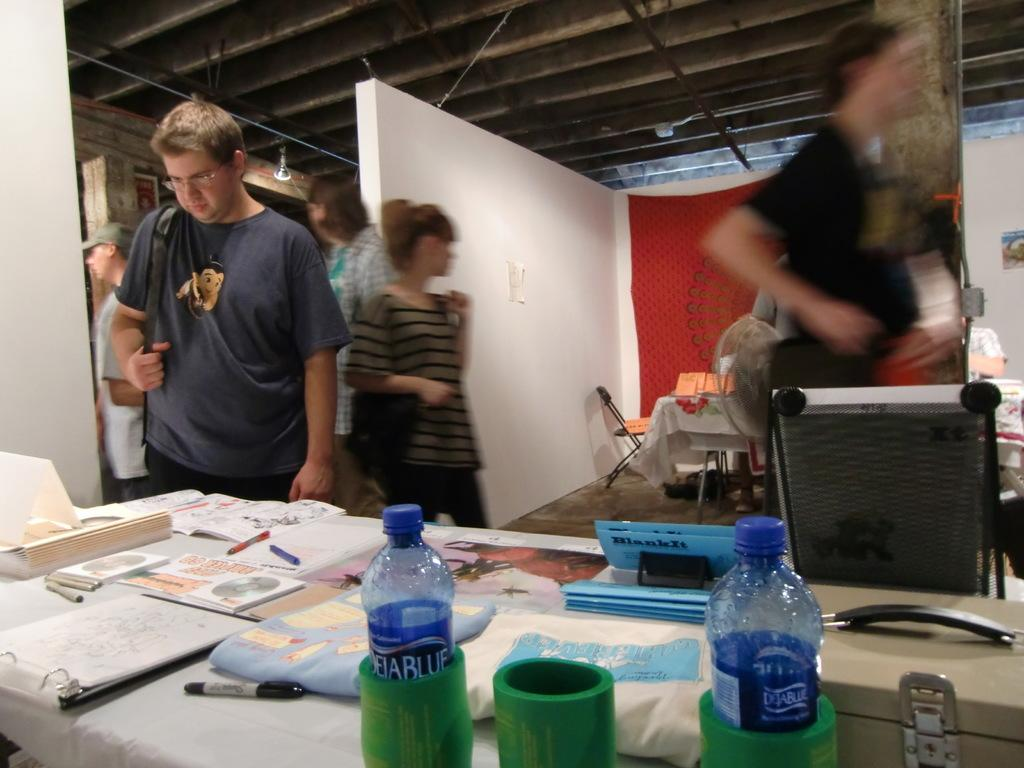Provide a one-sentence caption for the provided image. A room with tables that have DejaBlue water bottles on them and people walking by. 